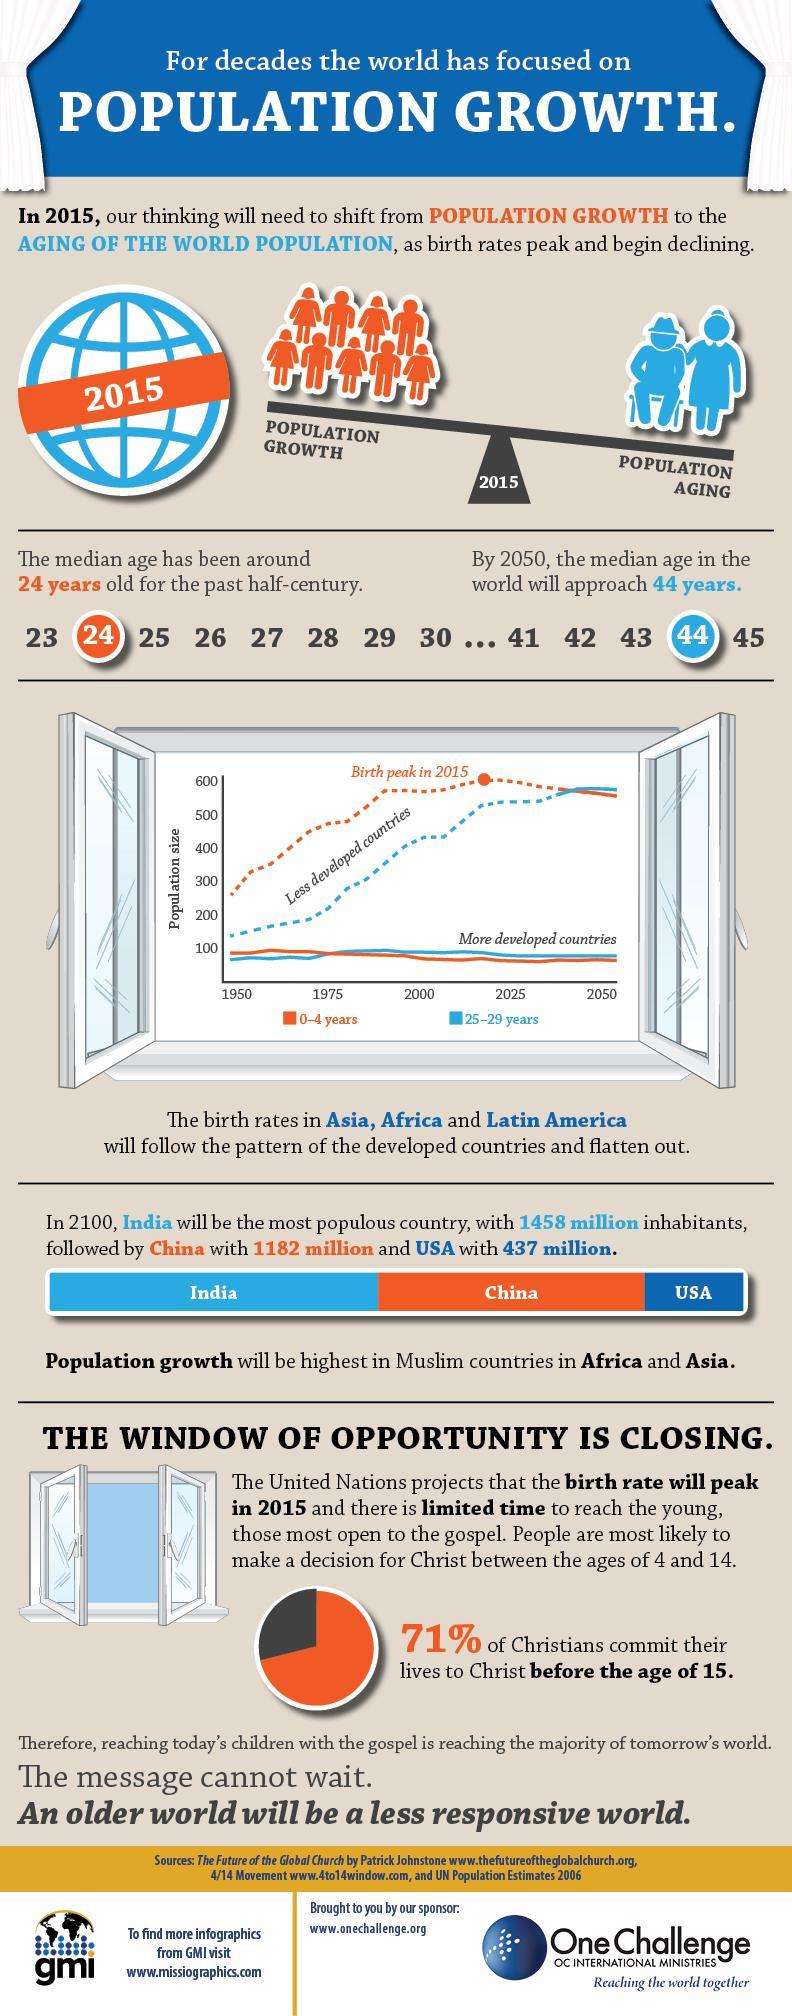What percentage of Christians didn't commit their lives to Christ before the age of 15?
Answer the question with a short phrase. 29% 